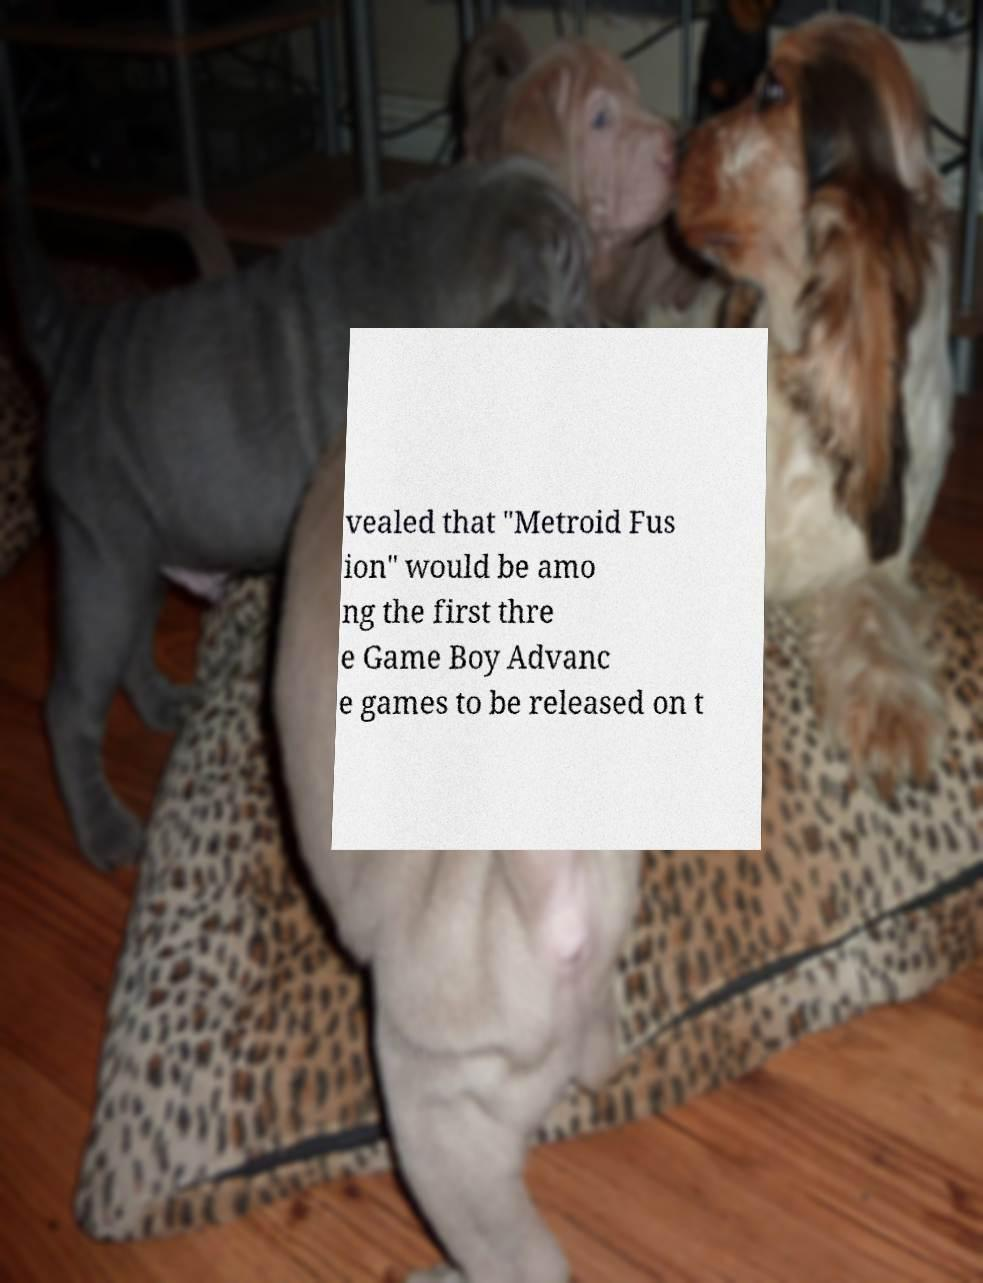Please read and relay the text visible in this image. What does it say? vealed that "Metroid Fus ion" would be amo ng the first thre e Game Boy Advanc e games to be released on t 